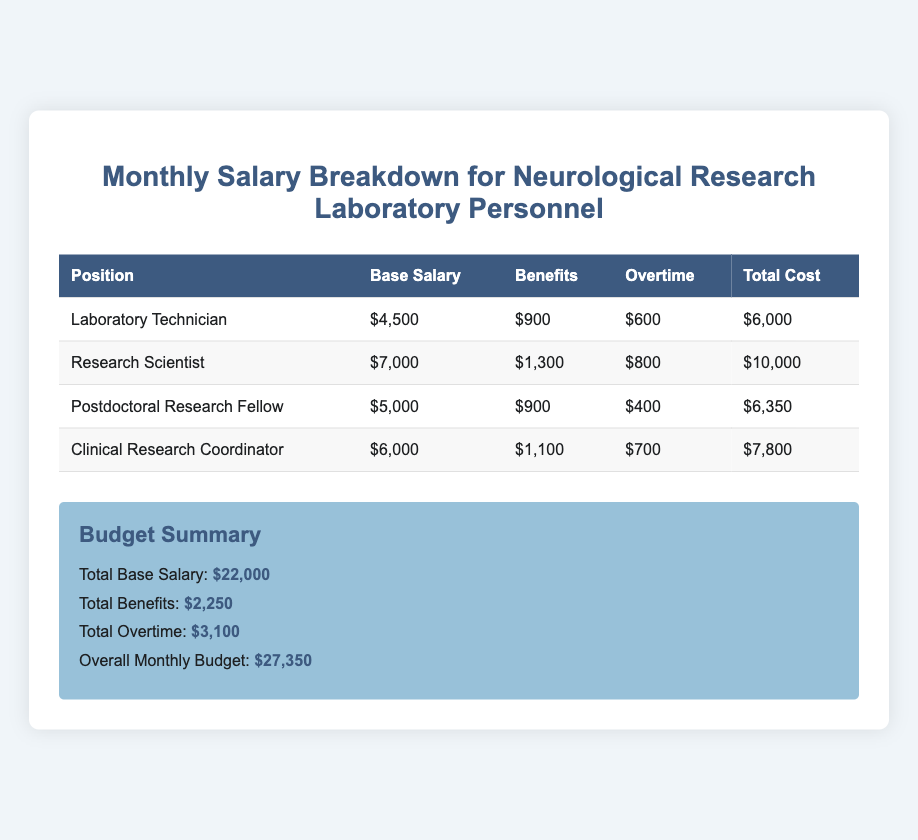What is the base salary of the Research Scientist? The base salary for the Research Scientist is listed in the document as $7,000.
Answer: $7,000 What is the total cost for the Clinical Research Coordinator? The total cost for the Clinical Research Coordinator is calculated from their base salary, benefits, and overtime, which equals $7,800.
Answer: $7,800 How much is spent on benefits for Laboratory Technicians? The benefits allocated for Laboratory Technicians are specified as $900 in the document.
Answer: $900 What is the total monthly budget for all personnel? The overall monthly budget is the sum of total base salaries, benefits, and overtime expenditures, which is $27,350.
Answer: $27,350 Which position has the highest total cost? The position with the highest total cost is the Research Scientist at $10,000.
Answer: Research Scientist What is the combined total for overtime across all positions? The combined total for overtime is the sum of all overtime amounts listed, which is $3,100.
Answer: $3,100 What percentage of the overall monthly budget is allocated to overtime? The total budget of $27,350 includes $3,100 for overtime; thus, the percentage is calculated accordingly, which is about 11.34%.
Answer: 11.34% What is the total base salary for all personnel? The total base salary sums are provided as $22,000.
Answer: $22,000 How many personnel positions are listed in the budget? The document lists four personnel positions involved in the neurological research.
Answer: Four 